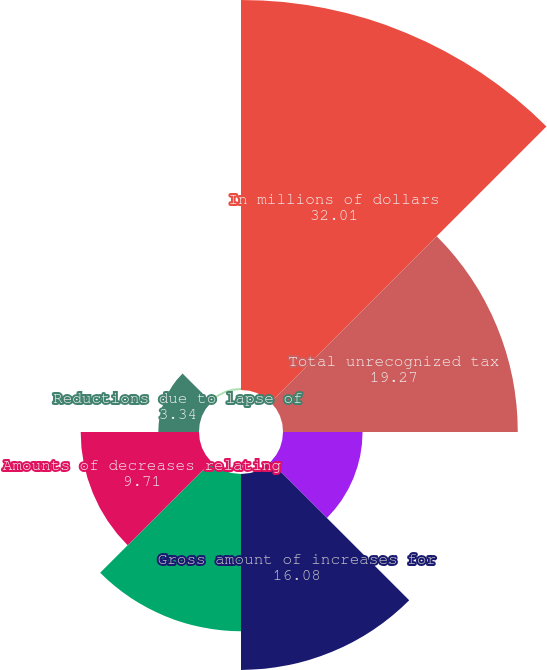Convert chart to OTSL. <chart><loc_0><loc_0><loc_500><loc_500><pie_chart><fcel>In millions of dollars<fcel>Total unrecognized tax<fcel>Net amount of increases for<fcel>Gross amount of increases for<fcel>Gross amount of decreases for<fcel>Amounts of decreases relating<fcel>Reductions due to lapse of<fcel>Foreign exchange acquisitions<nl><fcel>32.01%<fcel>19.27%<fcel>6.53%<fcel>16.08%<fcel>12.9%<fcel>9.71%<fcel>3.34%<fcel>0.16%<nl></chart> 